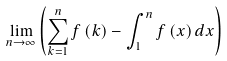<formula> <loc_0><loc_0><loc_500><loc_500>\lim _ { n \rightarrow \infty } \left ( \sum _ { k = 1 } ^ { n } f \left ( k \right ) - \int _ { 1 } ^ { n } f \left ( x \right ) d x \right )</formula> 